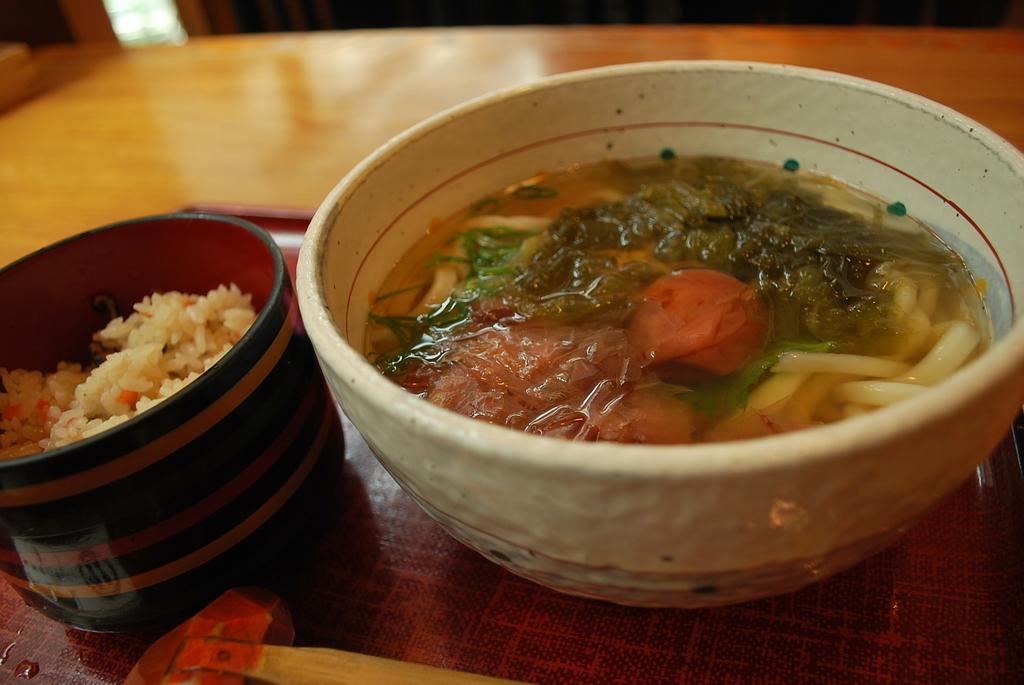What is the color of the tray in the image? The tray in the image is brown-colored. Where is the tray located? The tray is on a table. How many bowls are on the tray? There are two bowls on the tray. What is in the bowls? The bowls contain food items. How many boys are using the knot to secure the food items in the image? There are no boys or knots present in the image. 